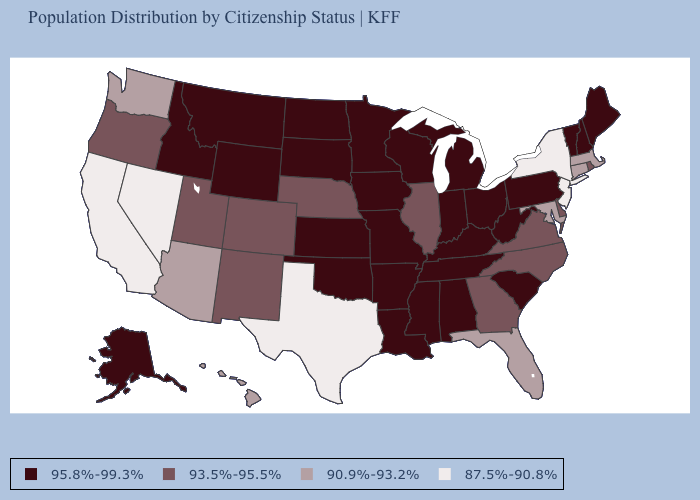Among the states that border Connecticut , does Massachusetts have the highest value?
Keep it brief. No. What is the lowest value in the West?
Keep it brief. 87.5%-90.8%. What is the value of Oregon?
Give a very brief answer. 93.5%-95.5%. Among the states that border Virginia , which have the lowest value?
Answer briefly. Maryland. What is the lowest value in states that border Georgia?
Answer briefly. 90.9%-93.2%. Which states have the highest value in the USA?
Answer briefly. Alabama, Alaska, Arkansas, Idaho, Indiana, Iowa, Kansas, Kentucky, Louisiana, Maine, Michigan, Minnesota, Mississippi, Missouri, Montana, New Hampshire, North Dakota, Ohio, Oklahoma, Pennsylvania, South Carolina, South Dakota, Tennessee, Vermont, West Virginia, Wisconsin, Wyoming. What is the value of Connecticut?
Concise answer only. 90.9%-93.2%. What is the value of Texas?
Be succinct. 87.5%-90.8%. Does Florida have the highest value in the USA?
Write a very short answer. No. Which states have the lowest value in the USA?
Answer briefly. California, Nevada, New Jersey, New York, Texas. Name the states that have a value in the range 93.5%-95.5%?
Concise answer only. Colorado, Delaware, Georgia, Illinois, Nebraska, New Mexico, North Carolina, Oregon, Rhode Island, Utah, Virginia. What is the value of Massachusetts?
Be succinct. 90.9%-93.2%. Among the states that border New Mexico , which have the lowest value?
Be succinct. Texas. How many symbols are there in the legend?
Short answer required. 4. 